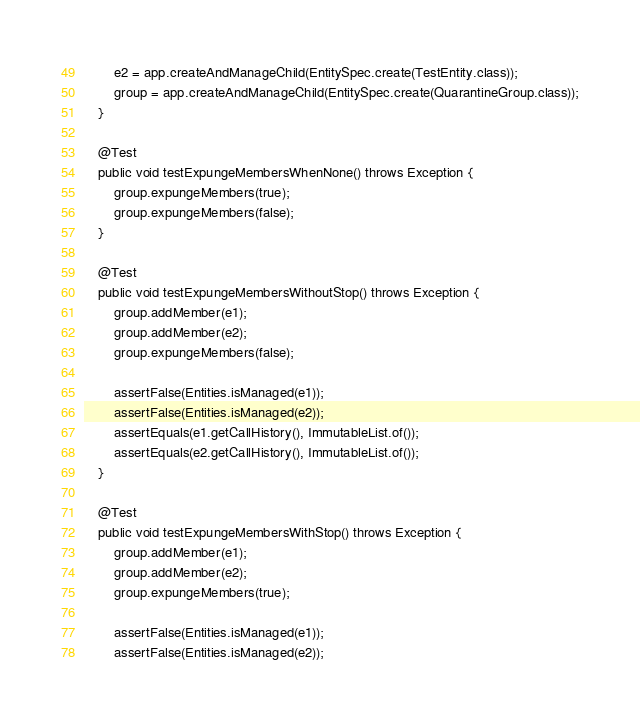Convert code to text. <code><loc_0><loc_0><loc_500><loc_500><_Java_>        e2 = app.createAndManageChild(EntitySpec.create(TestEntity.class));
        group = app.createAndManageChild(EntitySpec.create(QuarantineGroup.class));
    }

    @Test
    public void testExpungeMembersWhenNone() throws Exception {
        group.expungeMembers(true);
        group.expungeMembers(false);
    }
    
    @Test
    public void testExpungeMembersWithoutStop() throws Exception {
        group.addMember(e1);
        group.addMember(e2);
        group.expungeMembers(false);
        
        assertFalse(Entities.isManaged(e1));
        assertFalse(Entities.isManaged(e2));
        assertEquals(e1.getCallHistory(), ImmutableList.of());
        assertEquals(e2.getCallHistory(), ImmutableList.of());
    }

    @Test
    public void testExpungeMembersWithStop() throws Exception {
        group.addMember(e1);
        group.addMember(e2);
        group.expungeMembers(true);
        
        assertFalse(Entities.isManaged(e1));
        assertFalse(Entities.isManaged(e2));</code> 